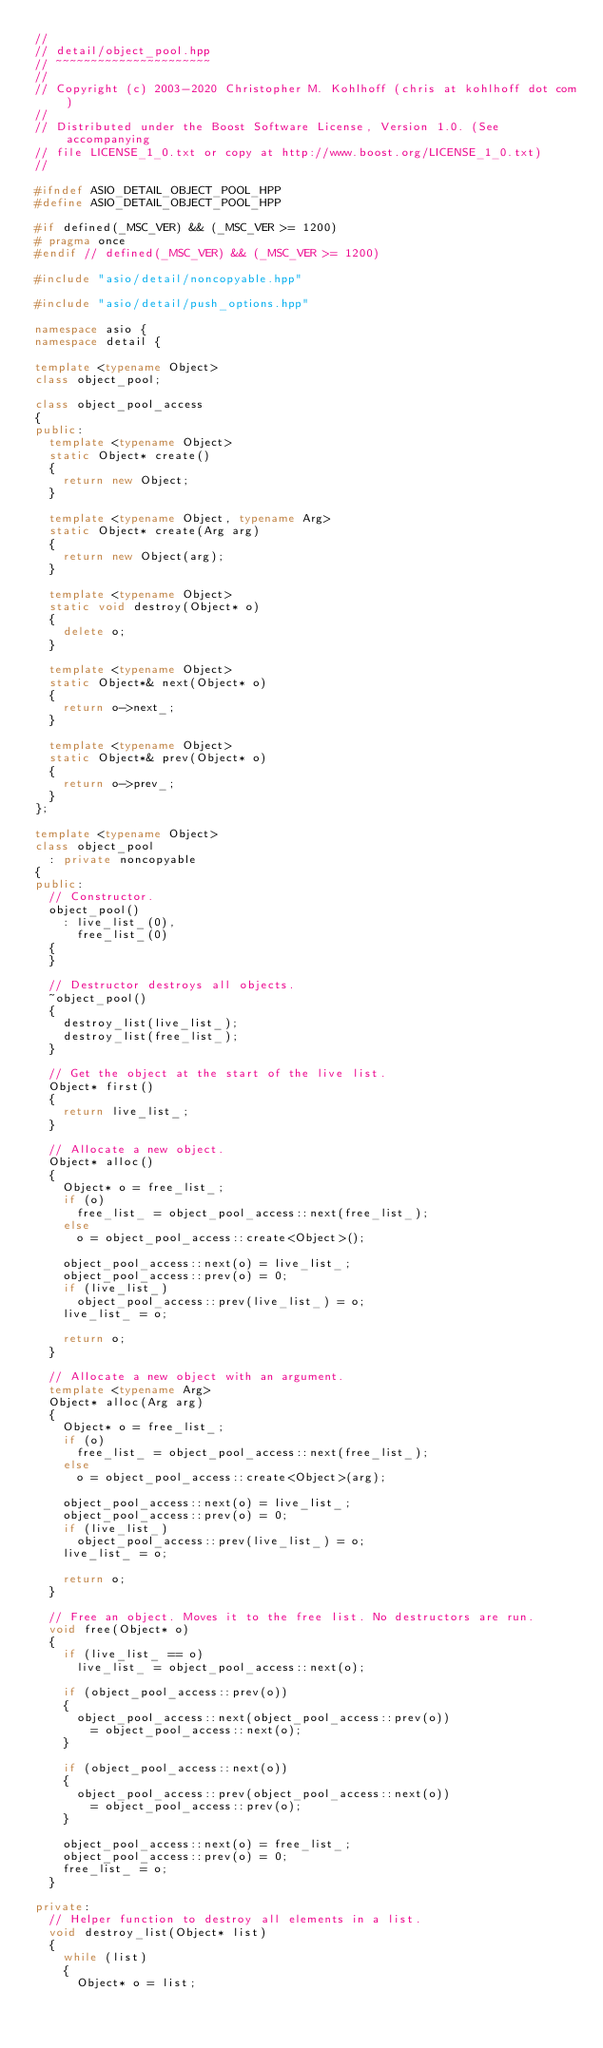<code> <loc_0><loc_0><loc_500><loc_500><_C++_>//
// detail/object_pool.hpp
// ~~~~~~~~~~~~~~~~~~~~~~
//
// Copyright (c) 2003-2020 Christopher M. Kohlhoff (chris at kohlhoff dot com)
//
// Distributed under the Boost Software License, Version 1.0. (See accompanying
// file LICENSE_1_0.txt or copy at http://www.boost.org/LICENSE_1_0.txt)
//

#ifndef ASIO_DETAIL_OBJECT_POOL_HPP
#define ASIO_DETAIL_OBJECT_POOL_HPP

#if defined(_MSC_VER) && (_MSC_VER >= 1200)
# pragma once
#endif // defined(_MSC_VER) && (_MSC_VER >= 1200)

#include "asio/detail/noncopyable.hpp"

#include "asio/detail/push_options.hpp"

namespace asio {
namespace detail {

template <typename Object>
class object_pool;

class object_pool_access
{
public:
  template <typename Object>
  static Object* create()
  {
    return new Object;
  }

  template <typename Object, typename Arg>
  static Object* create(Arg arg)
  {
    return new Object(arg);
  }

  template <typename Object>
  static void destroy(Object* o)
  {
    delete o;
  }

  template <typename Object>
  static Object*& next(Object* o)
  {
    return o->next_;
  }

  template <typename Object>
  static Object*& prev(Object* o)
  {
    return o->prev_;
  }
};

template <typename Object>
class object_pool
  : private noncopyable
{
public:
  // Constructor.
  object_pool()
    : live_list_(0),
      free_list_(0)
  {
  }

  // Destructor destroys all objects.
  ~object_pool()
  {
    destroy_list(live_list_);
    destroy_list(free_list_);
  }

  // Get the object at the start of the live list.
  Object* first()
  {
    return live_list_;
  }

  // Allocate a new object.
  Object* alloc()
  {
    Object* o = free_list_;
    if (o)
      free_list_ = object_pool_access::next(free_list_);
    else
      o = object_pool_access::create<Object>();

    object_pool_access::next(o) = live_list_;
    object_pool_access::prev(o) = 0;
    if (live_list_)
      object_pool_access::prev(live_list_) = o;
    live_list_ = o;

    return o;
  }

  // Allocate a new object with an argument.
  template <typename Arg>
  Object* alloc(Arg arg)
  {
    Object* o = free_list_;
    if (o)
      free_list_ = object_pool_access::next(free_list_);
    else
      o = object_pool_access::create<Object>(arg);

    object_pool_access::next(o) = live_list_;
    object_pool_access::prev(o) = 0;
    if (live_list_)
      object_pool_access::prev(live_list_) = o;
    live_list_ = o;

    return o;
  }

  // Free an object. Moves it to the free list. No destructors are run.
  void free(Object* o)
  {
    if (live_list_ == o)
      live_list_ = object_pool_access::next(o);

    if (object_pool_access::prev(o))
    {
      object_pool_access::next(object_pool_access::prev(o))
        = object_pool_access::next(o);
    }

    if (object_pool_access::next(o))
    {
      object_pool_access::prev(object_pool_access::next(o))
        = object_pool_access::prev(o);
    }

    object_pool_access::next(o) = free_list_;
    object_pool_access::prev(o) = 0;
    free_list_ = o;
  }

private:
  // Helper function to destroy all elements in a list.
  void destroy_list(Object* list)
  {
    while (list)
    {
      Object* o = list;</code> 